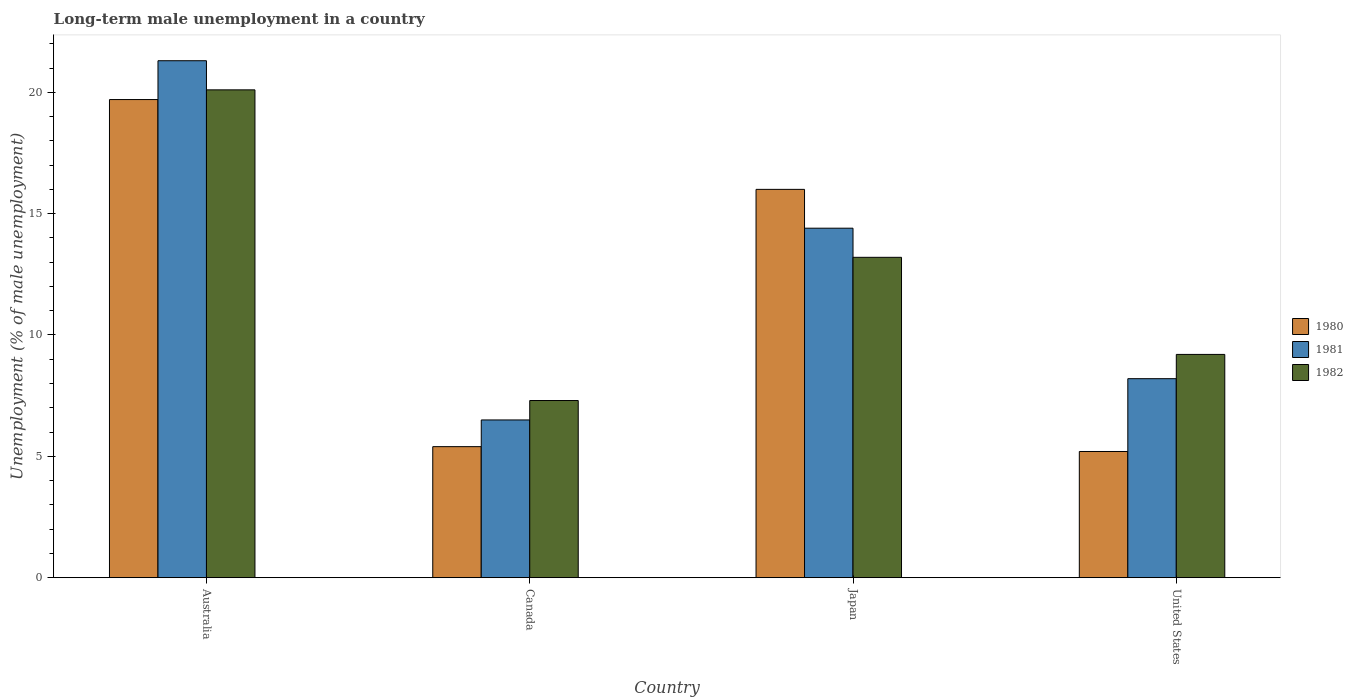How many different coloured bars are there?
Give a very brief answer. 3. How many groups of bars are there?
Offer a terse response. 4. Are the number of bars on each tick of the X-axis equal?
Your response must be concise. Yes. How many bars are there on the 2nd tick from the left?
Provide a succinct answer. 3. How many bars are there on the 1st tick from the right?
Your answer should be compact. 3. What is the label of the 4th group of bars from the left?
Your answer should be compact. United States. In how many cases, is the number of bars for a given country not equal to the number of legend labels?
Give a very brief answer. 0. What is the percentage of long-term unemployed male population in 1980 in United States?
Offer a very short reply. 5.2. Across all countries, what is the maximum percentage of long-term unemployed male population in 1980?
Provide a short and direct response. 19.7. In which country was the percentage of long-term unemployed male population in 1980 maximum?
Offer a very short reply. Australia. What is the total percentage of long-term unemployed male population in 1980 in the graph?
Your response must be concise. 46.3. What is the difference between the percentage of long-term unemployed male population in 1982 in Australia and that in United States?
Your response must be concise. 10.9. What is the difference between the percentage of long-term unemployed male population in 1981 in Canada and the percentage of long-term unemployed male population in 1982 in Japan?
Your answer should be compact. -6.7. What is the average percentage of long-term unemployed male population in 1982 per country?
Provide a succinct answer. 12.45. What is the difference between the percentage of long-term unemployed male population of/in 1981 and percentage of long-term unemployed male population of/in 1982 in Japan?
Give a very brief answer. 1.2. In how many countries, is the percentage of long-term unemployed male population in 1980 greater than 6 %?
Keep it short and to the point. 2. What is the ratio of the percentage of long-term unemployed male population in 1980 in Australia to that in Canada?
Keep it short and to the point. 3.65. Is the percentage of long-term unemployed male population in 1981 in Canada less than that in Japan?
Provide a short and direct response. Yes. What is the difference between the highest and the second highest percentage of long-term unemployed male population in 1980?
Your answer should be very brief. -3.7. What is the difference between the highest and the lowest percentage of long-term unemployed male population in 1980?
Make the answer very short. 14.5. In how many countries, is the percentage of long-term unemployed male population in 1982 greater than the average percentage of long-term unemployed male population in 1982 taken over all countries?
Your response must be concise. 2. What does the 3rd bar from the right in Canada represents?
Provide a succinct answer. 1980. Is it the case that in every country, the sum of the percentage of long-term unemployed male population in 1982 and percentage of long-term unemployed male population in 1981 is greater than the percentage of long-term unemployed male population in 1980?
Give a very brief answer. Yes. Are the values on the major ticks of Y-axis written in scientific E-notation?
Provide a short and direct response. No. Does the graph contain any zero values?
Your response must be concise. No. Does the graph contain grids?
Offer a terse response. No. Where does the legend appear in the graph?
Your response must be concise. Center right. How are the legend labels stacked?
Your answer should be very brief. Vertical. What is the title of the graph?
Provide a short and direct response. Long-term male unemployment in a country. What is the label or title of the Y-axis?
Ensure brevity in your answer.  Unemployment (% of male unemployment). What is the Unemployment (% of male unemployment) of 1980 in Australia?
Ensure brevity in your answer.  19.7. What is the Unemployment (% of male unemployment) in 1981 in Australia?
Provide a short and direct response. 21.3. What is the Unemployment (% of male unemployment) in 1982 in Australia?
Your answer should be very brief. 20.1. What is the Unemployment (% of male unemployment) of 1980 in Canada?
Give a very brief answer. 5.4. What is the Unemployment (% of male unemployment) in 1981 in Canada?
Your answer should be very brief. 6.5. What is the Unemployment (% of male unemployment) in 1982 in Canada?
Your answer should be very brief. 7.3. What is the Unemployment (% of male unemployment) in 1980 in Japan?
Your answer should be compact. 16. What is the Unemployment (% of male unemployment) in 1981 in Japan?
Your response must be concise. 14.4. What is the Unemployment (% of male unemployment) of 1982 in Japan?
Your answer should be compact. 13.2. What is the Unemployment (% of male unemployment) in 1980 in United States?
Ensure brevity in your answer.  5.2. What is the Unemployment (% of male unemployment) of 1981 in United States?
Your answer should be compact. 8.2. What is the Unemployment (% of male unemployment) of 1982 in United States?
Offer a very short reply. 9.2. Across all countries, what is the maximum Unemployment (% of male unemployment) of 1980?
Make the answer very short. 19.7. Across all countries, what is the maximum Unemployment (% of male unemployment) of 1981?
Your response must be concise. 21.3. Across all countries, what is the maximum Unemployment (% of male unemployment) in 1982?
Keep it short and to the point. 20.1. Across all countries, what is the minimum Unemployment (% of male unemployment) of 1980?
Offer a terse response. 5.2. Across all countries, what is the minimum Unemployment (% of male unemployment) of 1982?
Your answer should be compact. 7.3. What is the total Unemployment (% of male unemployment) in 1980 in the graph?
Provide a succinct answer. 46.3. What is the total Unemployment (% of male unemployment) in 1981 in the graph?
Provide a succinct answer. 50.4. What is the total Unemployment (% of male unemployment) of 1982 in the graph?
Provide a short and direct response. 49.8. What is the difference between the Unemployment (% of male unemployment) in 1981 in Australia and that in Japan?
Your response must be concise. 6.9. What is the difference between the Unemployment (% of male unemployment) of 1982 in Australia and that in Japan?
Your answer should be compact. 6.9. What is the difference between the Unemployment (% of male unemployment) of 1980 in Australia and that in United States?
Offer a very short reply. 14.5. What is the difference between the Unemployment (% of male unemployment) in 1981 in Australia and that in United States?
Offer a very short reply. 13.1. What is the difference between the Unemployment (% of male unemployment) of 1982 in Australia and that in United States?
Provide a succinct answer. 10.9. What is the difference between the Unemployment (% of male unemployment) of 1982 in Canada and that in Japan?
Your answer should be compact. -5.9. What is the difference between the Unemployment (% of male unemployment) of 1982 in Canada and that in United States?
Your answer should be compact. -1.9. What is the difference between the Unemployment (% of male unemployment) in 1980 in Japan and that in United States?
Your answer should be compact. 10.8. What is the difference between the Unemployment (% of male unemployment) in 1981 in Japan and that in United States?
Your response must be concise. 6.2. What is the difference between the Unemployment (% of male unemployment) in 1980 in Australia and the Unemployment (% of male unemployment) in 1981 in Canada?
Offer a very short reply. 13.2. What is the difference between the Unemployment (% of male unemployment) of 1980 in Australia and the Unemployment (% of male unemployment) of 1982 in Japan?
Offer a terse response. 6.5. What is the difference between the Unemployment (% of male unemployment) in 1980 in Australia and the Unemployment (% of male unemployment) in 1981 in United States?
Keep it short and to the point. 11.5. What is the difference between the Unemployment (% of male unemployment) of 1980 in Australia and the Unemployment (% of male unemployment) of 1982 in United States?
Make the answer very short. 10.5. What is the difference between the Unemployment (% of male unemployment) in 1980 in Canada and the Unemployment (% of male unemployment) in 1981 in Japan?
Your answer should be very brief. -9. What is the difference between the Unemployment (% of male unemployment) in 1980 in Canada and the Unemployment (% of male unemployment) in 1982 in Japan?
Provide a short and direct response. -7.8. What is the difference between the Unemployment (% of male unemployment) in 1981 in Canada and the Unemployment (% of male unemployment) in 1982 in Japan?
Provide a succinct answer. -6.7. What is the difference between the Unemployment (% of male unemployment) of 1980 in Canada and the Unemployment (% of male unemployment) of 1982 in United States?
Offer a terse response. -3.8. What is the difference between the Unemployment (% of male unemployment) of 1981 in Canada and the Unemployment (% of male unemployment) of 1982 in United States?
Offer a terse response. -2.7. What is the average Unemployment (% of male unemployment) of 1980 per country?
Make the answer very short. 11.57. What is the average Unemployment (% of male unemployment) of 1981 per country?
Your response must be concise. 12.6. What is the average Unemployment (% of male unemployment) in 1982 per country?
Offer a very short reply. 12.45. What is the difference between the Unemployment (% of male unemployment) in 1980 and Unemployment (% of male unemployment) in 1982 in Australia?
Your answer should be compact. -0.4. What is the difference between the Unemployment (% of male unemployment) in 1981 and Unemployment (% of male unemployment) in 1982 in Australia?
Keep it short and to the point. 1.2. What is the difference between the Unemployment (% of male unemployment) of 1980 and Unemployment (% of male unemployment) of 1981 in Canada?
Offer a very short reply. -1.1. What is the difference between the Unemployment (% of male unemployment) of 1980 and Unemployment (% of male unemployment) of 1981 in Japan?
Offer a very short reply. 1.6. What is the difference between the Unemployment (% of male unemployment) in 1980 and Unemployment (% of male unemployment) in 1982 in Japan?
Make the answer very short. 2.8. What is the difference between the Unemployment (% of male unemployment) in 1980 and Unemployment (% of male unemployment) in 1981 in United States?
Offer a very short reply. -3. What is the ratio of the Unemployment (% of male unemployment) of 1980 in Australia to that in Canada?
Make the answer very short. 3.65. What is the ratio of the Unemployment (% of male unemployment) of 1981 in Australia to that in Canada?
Offer a terse response. 3.28. What is the ratio of the Unemployment (% of male unemployment) of 1982 in Australia to that in Canada?
Provide a succinct answer. 2.75. What is the ratio of the Unemployment (% of male unemployment) of 1980 in Australia to that in Japan?
Provide a succinct answer. 1.23. What is the ratio of the Unemployment (% of male unemployment) of 1981 in Australia to that in Japan?
Offer a very short reply. 1.48. What is the ratio of the Unemployment (% of male unemployment) of 1982 in Australia to that in Japan?
Ensure brevity in your answer.  1.52. What is the ratio of the Unemployment (% of male unemployment) in 1980 in Australia to that in United States?
Keep it short and to the point. 3.79. What is the ratio of the Unemployment (% of male unemployment) of 1981 in Australia to that in United States?
Offer a very short reply. 2.6. What is the ratio of the Unemployment (% of male unemployment) of 1982 in Australia to that in United States?
Offer a terse response. 2.18. What is the ratio of the Unemployment (% of male unemployment) of 1980 in Canada to that in Japan?
Provide a succinct answer. 0.34. What is the ratio of the Unemployment (% of male unemployment) in 1981 in Canada to that in Japan?
Make the answer very short. 0.45. What is the ratio of the Unemployment (% of male unemployment) in 1982 in Canada to that in Japan?
Ensure brevity in your answer.  0.55. What is the ratio of the Unemployment (% of male unemployment) of 1981 in Canada to that in United States?
Ensure brevity in your answer.  0.79. What is the ratio of the Unemployment (% of male unemployment) in 1982 in Canada to that in United States?
Keep it short and to the point. 0.79. What is the ratio of the Unemployment (% of male unemployment) in 1980 in Japan to that in United States?
Your answer should be very brief. 3.08. What is the ratio of the Unemployment (% of male unemployment) in 1981 in Japan to that in United States?
Provide a short and direct response. 1.76. What is the ratio of the Unemployment (% of male unemployment) in 1982 in Japan to that in United States?
Give a very brief answer. 1.43. What is the difference between the highest and the second highest Unemployment (% of male unemployment) in 1982?
Offer a very short reply. 6.9. What is the difference between the highest and the lowest Unemployment (% of male unemployment) in 1981?
Make the answer very short. 14.8. What is the difference between the highest and the lowest Unemployment (% of male unemployment) in 1982?
Your answer should be compact. 12.8. 